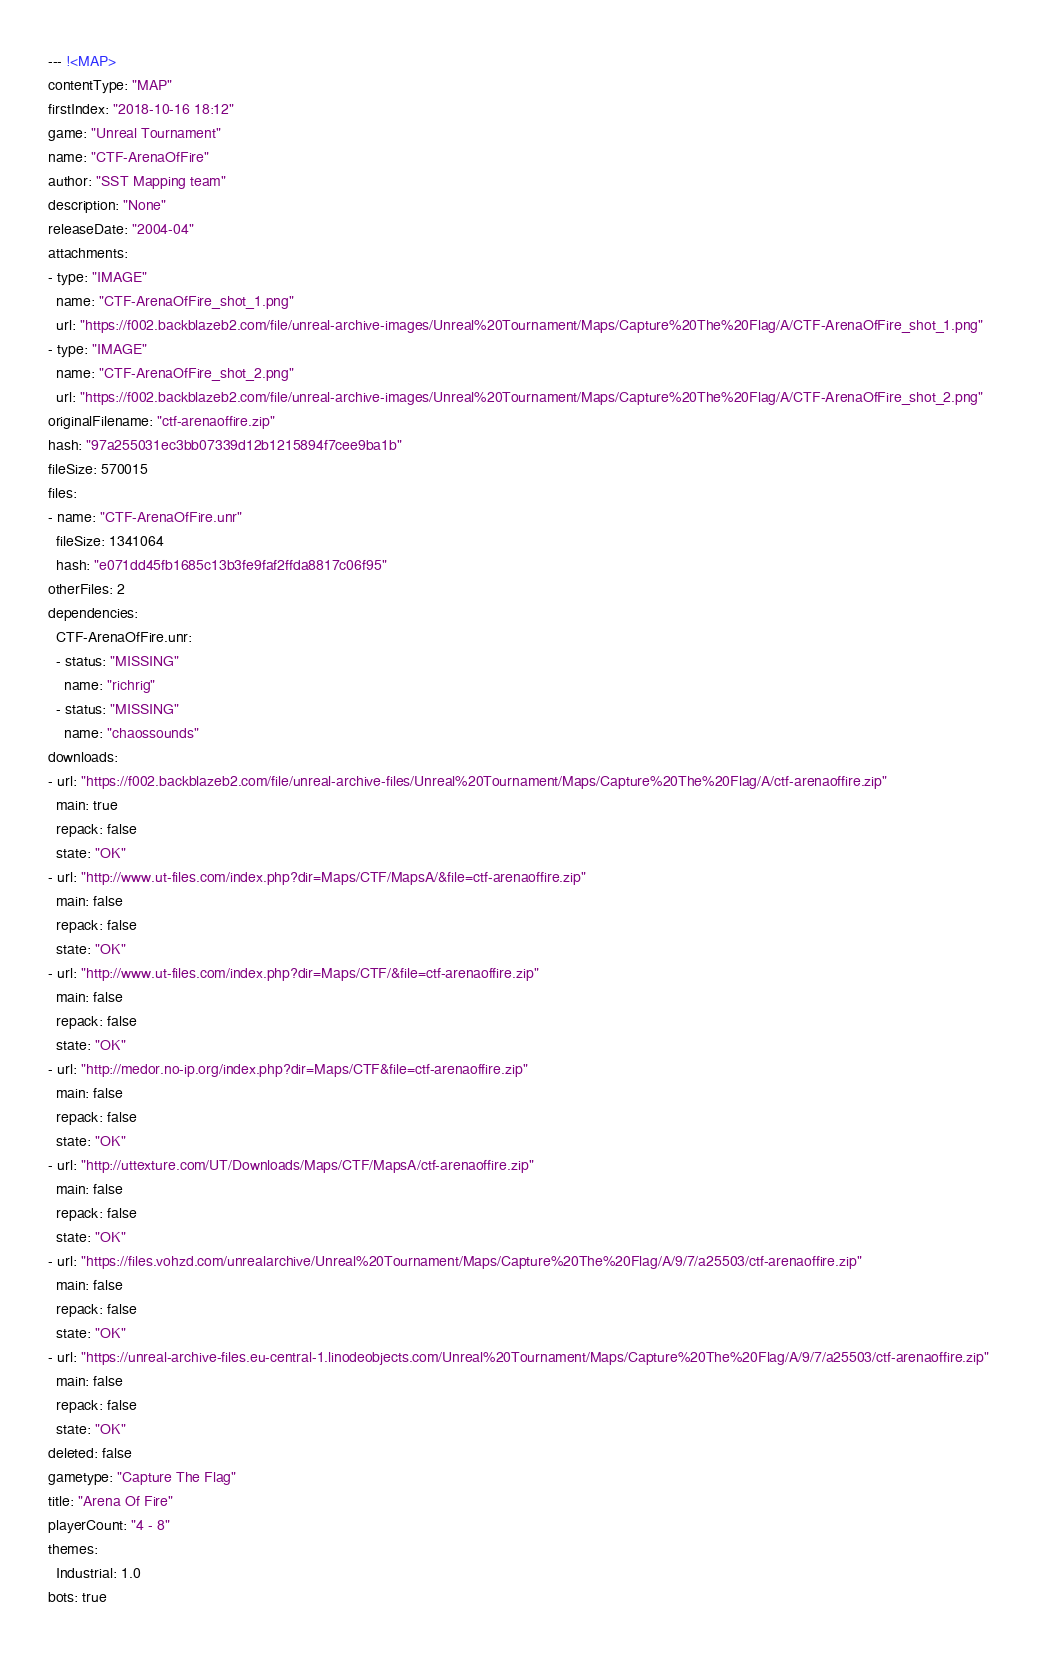Convert code to text. <code><loc_0><loc_0><loc_500><loc_500><_YAML_>--- !<MAP>
contentType: "MAP"
firstIndex: "2018-10-16 18:12"
game: "Unreal Tournament"
name: "CTF-ArenaOfFire"
author: "SST Mapping team"
description: "None"
releaseDate: "2004-04"
attachments:
- type: "IMAGE"
  name: "CTF-ArenaOfFire_shot_1.png"
  url: "https://f002.backblazeb2.com/file/unreal-archive-images/Unreal%20Tournament/Maps/Capture%20The%20Flag/A/CTF-ArenaOfFire_shot_1.png"
- type: "IMAGE"
  name: "CTF-ArenaOfFire_shot_2.png"
  url: "https://f002.backblazeb2.com/file/unreal-archive-images/Unreal%20Tournament/Maps/Capture%20The%20Flag/A/CTF-ArenaOfFire_shot_2.png"
originalFilename: "ctf-arenaoffire.zip"
hash: "97a255031ec3bb07339d12b1215894f7cee9ba1b"
fileSize: 570015
files:
- name: "CTF-ArenaOfFire.unr"
  fileSize: 1341064
  hash: "e071dd45fb1685c13b3fe9faf2ffda8817c06f95"
otherFiles: 2
dependencies:
  CTF-ArenaOfFire.unr:
  - status: "MISSING"
    name: "richrig"
  - status: "MISSING"
    name: "chaossounds"
downloads:
- url: "https://f002.backblazeb2.com/file/unreal-archive-files/Unreal%20Tournament/Maps/Capture%20The%20Flag/A/ctf-arenaoffire.zip"
  main: true
  repack: false
  state: "OK"
- url: "http://www.ut-files.com/index.php?dir=Maps/CTF/MapsA/&file=ctf-arenaoffire.zip"
  main: false
  repack: false
  state: "OK"
- url: "http://www.ut-files.com/index.php?dir=Maps/CTF/&file=ctf-arenaoffire.zip"
  main: false
  repack: false
  state: "OK"
- url: "http://medor.no-ip.org/index.php?dir=Maps/CTF&file=ctf-arenaoffire.zip"
  main: false
  repack: false
  state: "OK"
- url: "http://uttexture.com/UT/Downloads/Maps/CTF/MapsA/ctf-arenaoffire.zip"
  main: false
  repack: false
  state: "OK"
- url: "https://files.vohzd.com/unrealarchive/Unreal%20Tournament/Maps/Capture%20The%20Flag/A/9/7/a25503/ctf-arenaoffire.zip"
  main: false
  repack: false
  state: "OK"
- url: "https://unreal-archive-files.eu-central-1.linodeobjects.com/Unreal%20Tournament/Maps/Capture%20The%20Flag/A/9/7/a25503/ctf-arenaoffire.zip"
  main: false
  repack: false
  state: "OK"
deleted: false
gametype: "Capture The Flag"
title: "Arena Of Fire"
playerCount: "4 - 8"
themes:
  Industrial: 1.0
bots: true
</code> 